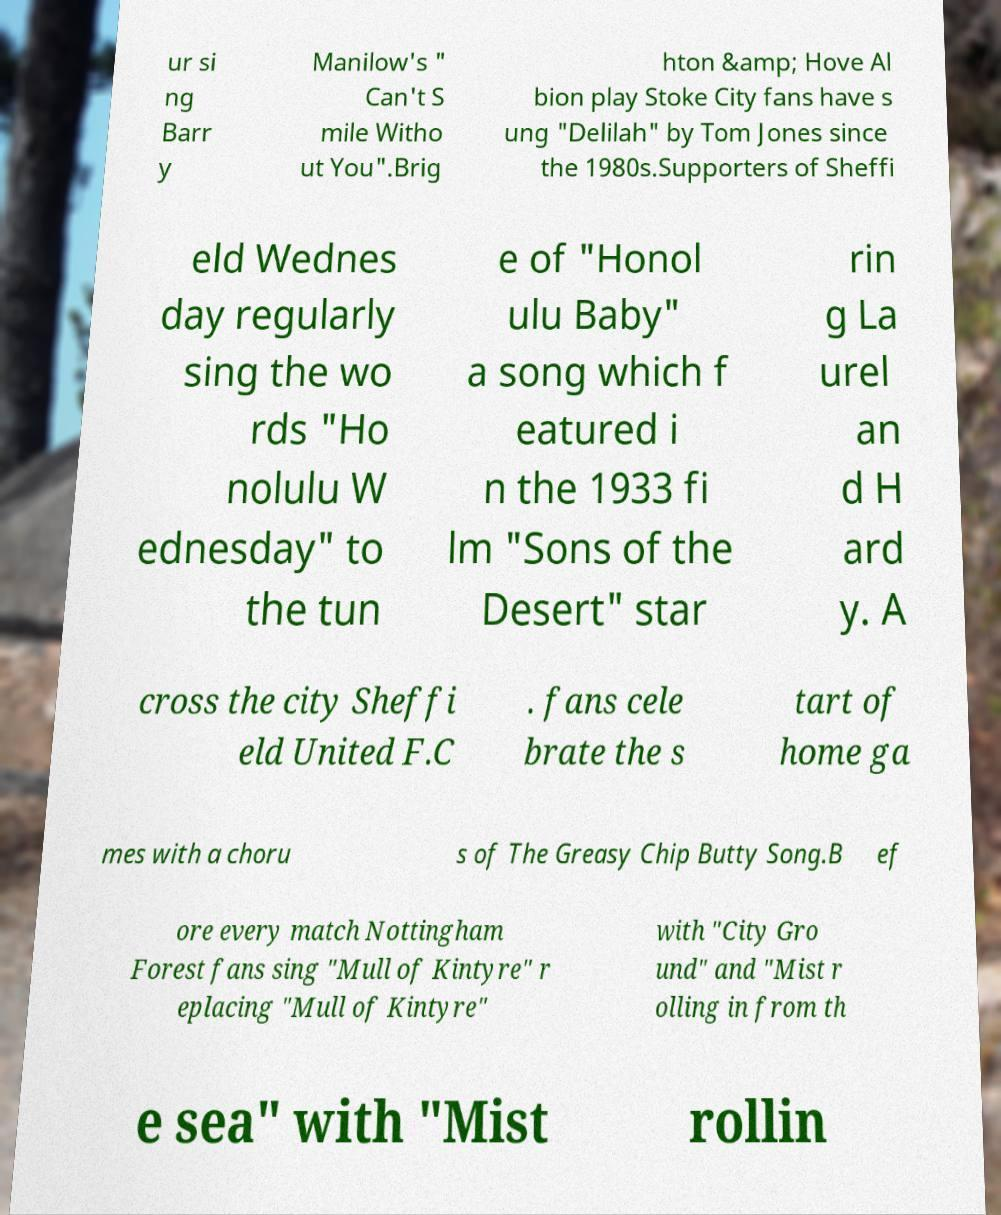For documentation purposes, I need the text within this image transcribed. Could you provide that? ur si ng Barr y Manilow's " Can't S mile Witho ut You".Brig hton &amp; Hove Al bion play Stoke City fans have s ung "Delilah" by Tom Jones since the 1980s.Supporters of Sheffi eld Wednes day regularly sing the wo rds "Ho nolulu W ednesday" to the tun e of "Honol ulu Baby" a song which f eatured i n the 1933 fi lm "Sons of the Desert" star rin g La urel an d H ard y. A cross the city Sheffi eld United F.C . fans cele brate the s tart of home ga mes with a choru s of The Greasy Chip Butty Song.B ef ore every match Nottingham Forest fans sing "Mull of Kintyre" r eplacing "Mull of Kintyre" with "City Gro und" and "Mist r olling in from th e sea" with "Mist rollin 